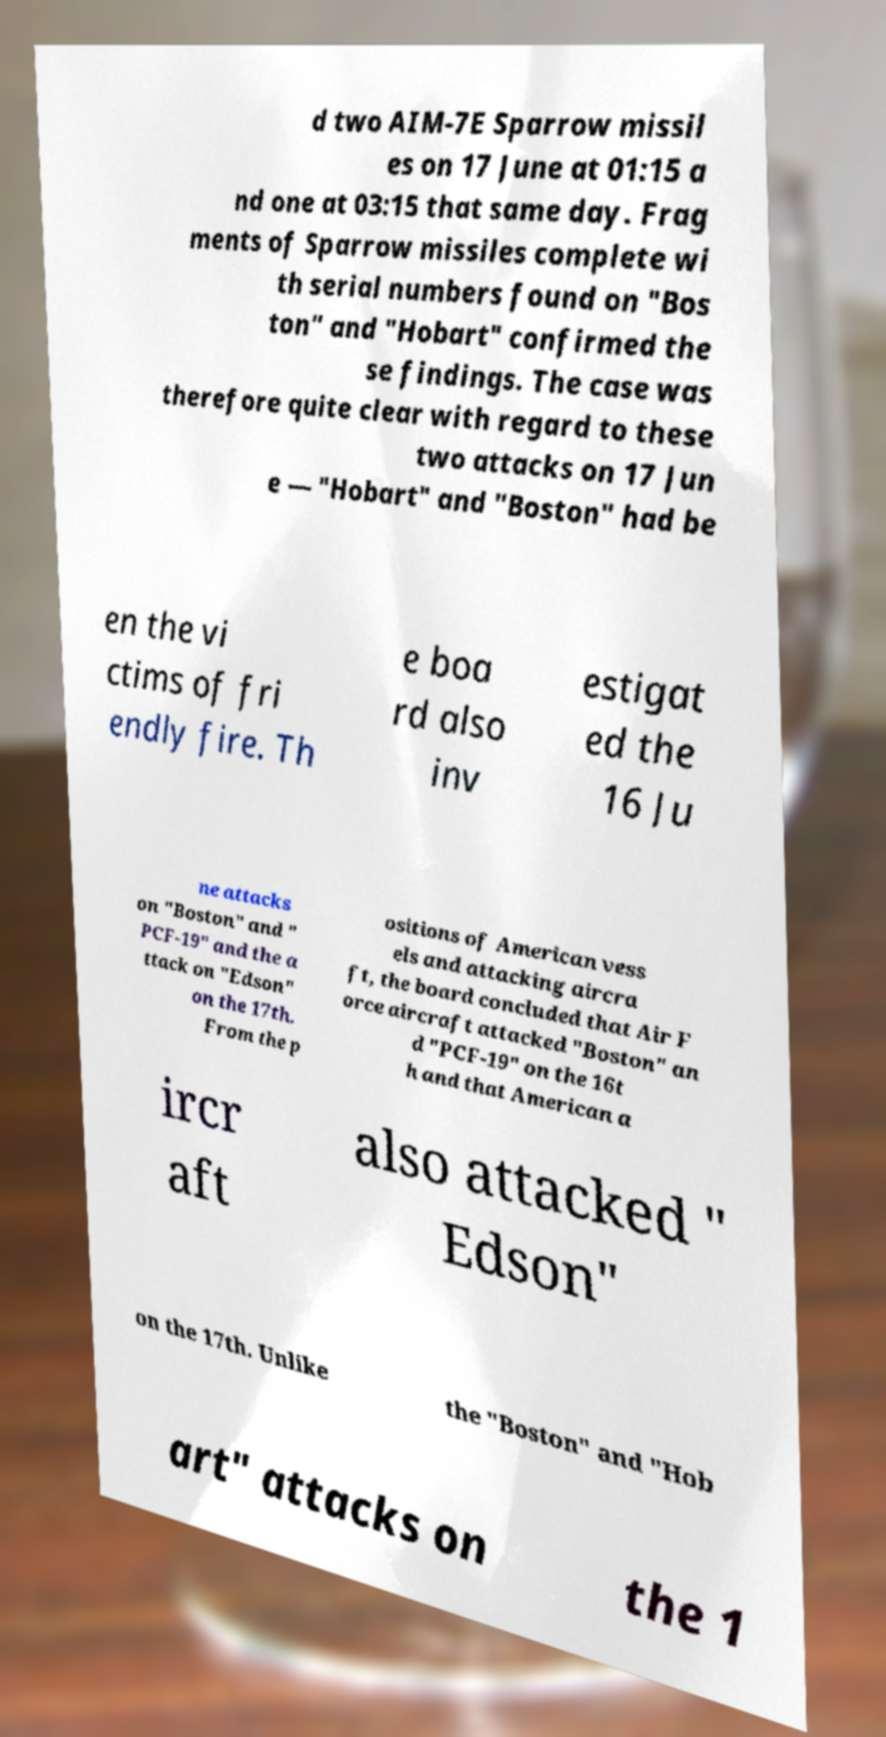Could you assist in decoding the text presented in this image and type it out clearly? d two AIM-7E Sparrow missil es on 17 June at 01:15 a nd one at 03:15 that same day. Frag ments of Sparrow missiles complete wi th serial numbers found on "Bos ton" and "Hobart" confirmed the se findings. The case was therefore quite clear with regard to these two attacks on 17 Jun e — "Hobart" and "Boston" had be en the vi ctims of fri endly fire. Th e boa rd also inv estigat ed the 16 Ju ne attacks on "Boston" and " PCF-19" and the a ttack on "Edson" on the 17th. From the p ositions of American vess els and attacking aircra ft, the board concluded that Air F orce aircraft attacked "Boston" an d "PCF-19" on the 16t h and that American a ircr aft also attacked " Edson" on the 17th. Unlike the "Boston" and "Hob art" attacks on the 1 